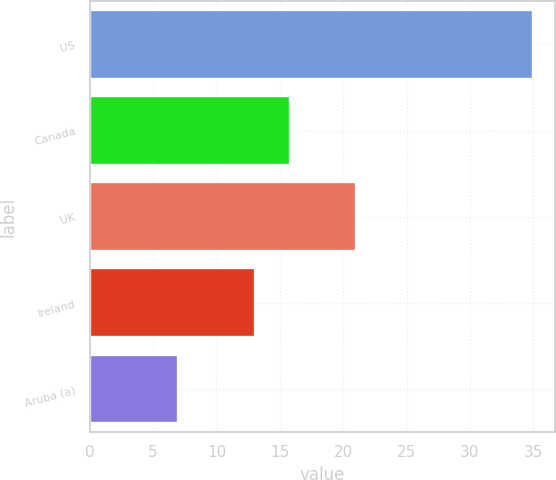<chart> <loc_0><loc_0><loc_500><loc_500><bar_chart><fcel>US<fcel>Canada<fcel>UK<fcel>Ireland<fcel>Aruba (a)<nl><fcel>35<fcel>15.8<fcel>21<fcel>13<fcel>7<nl></chart> 